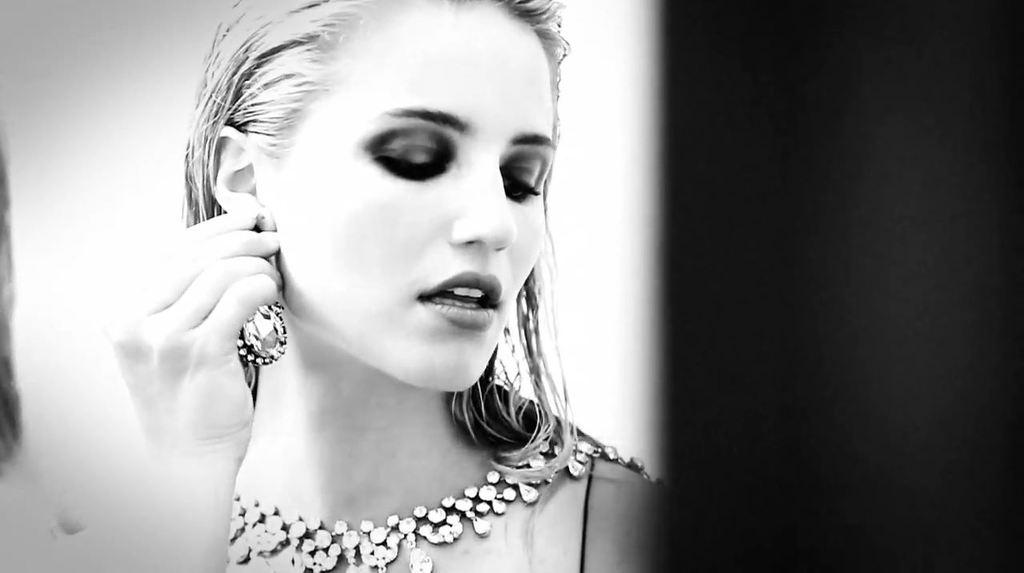Who is the main subject in the image? There is a woman in the image. Where is the woman located in the image? The woman is in the center of the image. What is the woman holding in the image? The woman is holding an earring. What type of screw can be seen in the woman's hair in the image? There is no screw present in the woman's hair or in the image. 